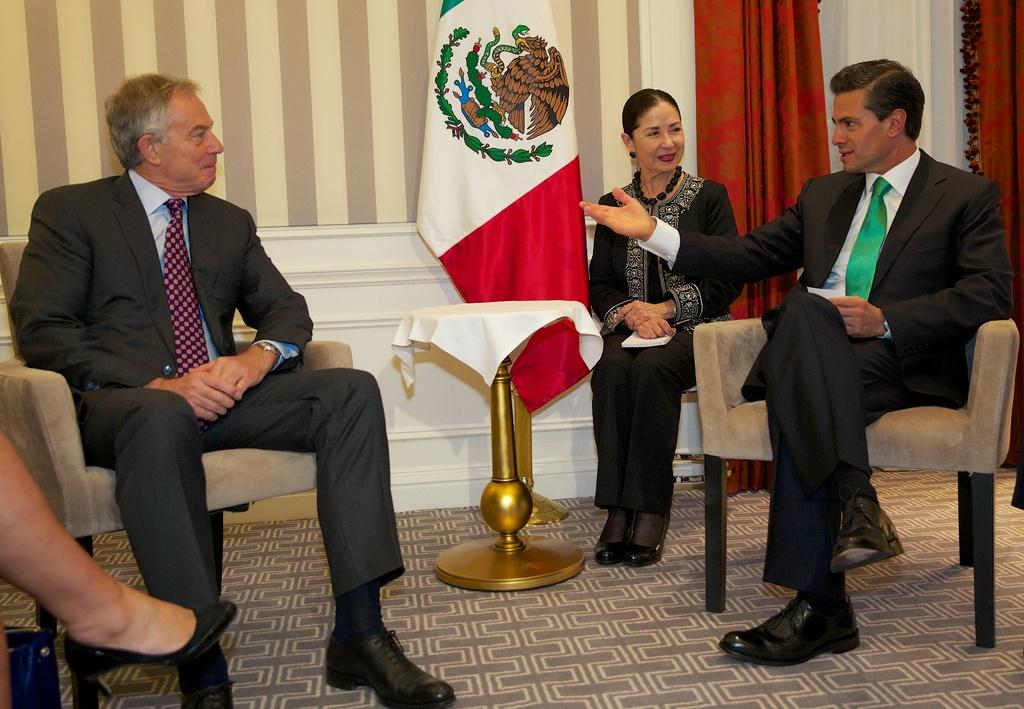What are the people in the image doing? The people in the image are sitting on chairs. What can be seen on the stand in the image? There is a white cloth present on the stand. What is the color of the flag visible in the image? The flag visible in the image is not described in terms of color. What type of fabric is used for the curtain in the image? The curtain in the image is red. What type of toothbrush is used to clean the flag in the image? There is no toothbrush present in the image, and the flag is not being cleaned. 